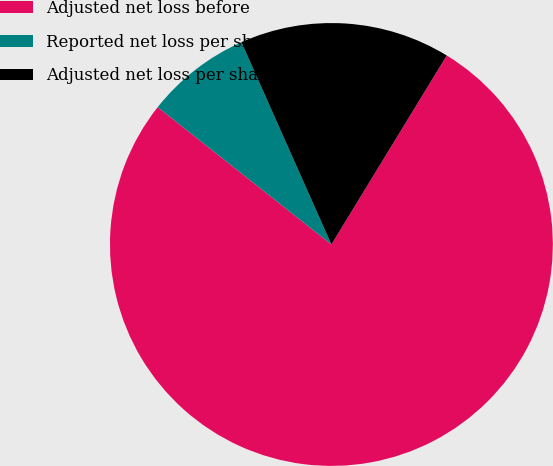<chart> <loc_0><loc_0><loc_500><loc_500><pie_chart><fcel>Adjusted net loss before<fcel>Reported net loss per share<fcel>Adjusted net loss per share<nl><fcel>76.92%<fcel>7.69%<fcel>15.38%<nl></chart> 